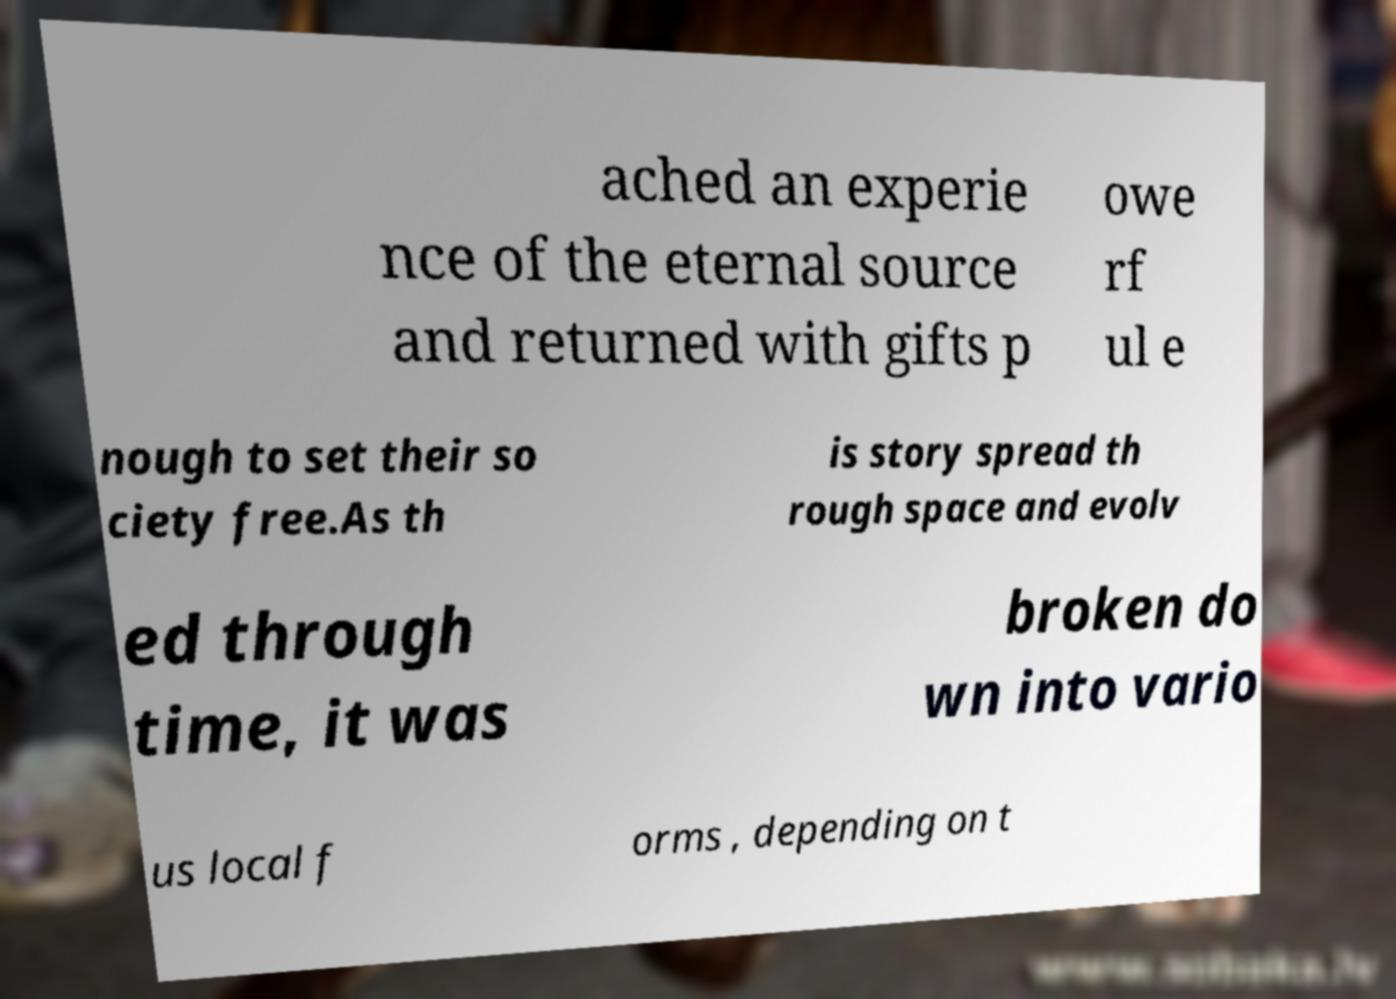I need the written content from this picture converted into text. Can you do that? ached an experie nce of the eternal source and returned with gifts p owe rf ul e nough to set their so ciety free.As th is story spread th rough space and evolv ed through time, it was broken do wn into vario us local f orms , depending on t 